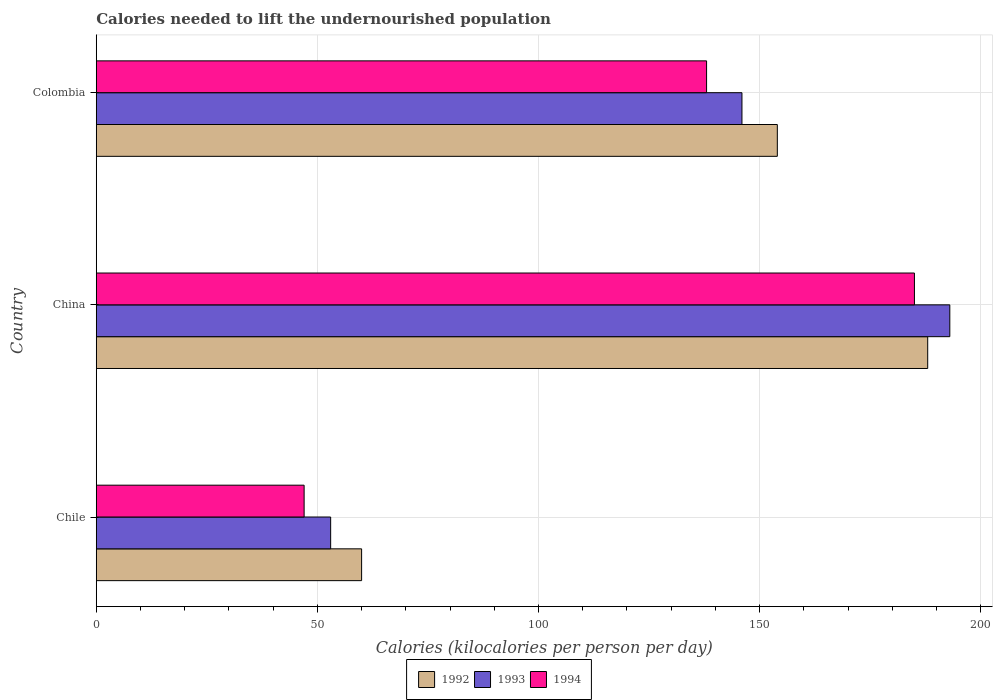How many different coloured bars are there?
Ensure brevity in your answer.  3. How many groups of bars are there?
Offer a very short reply. 3. Are the number of bars per tick equal to the number of legend labels?
Offer a terse response. Yes. Are the number of bars on each tick of the Y-axis equal?
Provide a succinct answer. Yes. How many bars are there on the 3rd tick from the top?
Ensure brevity in your answer.  3. What is the label of the 2nd group of bars from the top?
Make the answer very short. China. In how many cases, is the number of bars for a given country not equal to the number of legend labels?
Give a very brief answer. 0. Across all countries, what is the maximum total calories needed to lift the undernourished population in 1992?
Give a very brief answer. 188. In which country was the total calories needed to lift the undernourished population in 1992 minimum?
Keep it short and to the point. Chile. What is the total total calories needed to lift the undernourished population in 1994 in the graph?
Keep it short and to the point. 370. What is the difference between the total calories needed to lift the undernourished population in 1992 in Chile and that in China?
Your response must be concise. -128. What is the difference between the total calories needed to lift the undernourished population in 1992 in China and the total calories needed to lift the undernourished population in 1994 in Chile?
Your answer should be very brief. 141. What is the average total calories needed to lift the undernourished population in 1992 per country?
Ensure brevity in your answer.  134. What is the difference between the total calories needed to lift the undernourished population in 1994 and total calories needed to lift the undernourished population in 1992 in China?
Make the answer very short. -3. What is the ratio of the total calories needed to lift the undernourished population in 1992 in China to that in Colombia?
Keep it short and to the point. 1.22. Is the total calories needed to lift the undernourished population in 1994 in Chile less than that in China?
Ensure brevity in your answer.  Yes. What is the difference between the highest and the lowest total calories needed to lift the undernourished population in 1992?
Your answer should be very brief. 128. Is the sum of the total calories needed to lift the undernourished population in 1994 in Chile and Colombia greater than the maximum total calories needed to lift the undernourished population in 1992 across all countries?
Give a very brief answer. No. What does the 1st bar from the top in Chile represents?
Make the answer very short. 1994. What does the 3rd bar from the bottom in Chile represents?
Your response must be concise. 1994. Is it the case that in every country, the sum of the total calories needed to lift the undernourished population in 1992 and total calories needed to lift the undernourished population in 1993 is greater than the total calories needed to lift the undernourished population in 1994?
Make the answer very short. Yes. How many countries are there in the graph?
Provide a short and direct response. 3. What is the difference between two consecutive major ticks on the X-axis?
Keep it short and to the point. 50. Are the values on the major ticks of X-axis written in scientific E-notation?
Give a very brief answer. No. Where does the legend appear in the graph?
Your answer should be compact. Bottom center. What is the title of the graph?
Your answer should be very brief. Calories needed to lift the undernourished population. What is the label or title of the X-axis?
Your answer should be very brief. Calories (kilocalories per person per day). What is the label or title of the Y-axis?
Ensure brevity in your answer.  Country. What is the Calories (kilocalories per person per day) in 1993 in Chile?
Keep it short and to the point. 53. What is the Calories (kilocalories per person per day) in 1994 in Chile?
Your response must be concise. 47. What is the Calories (kilocalories per person per day) in 1992 in China?
Keep it short and to the point. 188. What is the Calories (kilocalories per person per day) in 1993 in China?
Provide a succinct answer. 193. What is the Calories (kilocalories per person per day) of 1994 in China?
Your answer should be compact. 185. What is the Calories (kilocalories per person per day) of 1992 in Colombia?
Make the answer very short. 154. What is the Calories (kilocalories per person per day) of 1993 in Colombia?
Your answer should be compact. 146. What is the Calories (kilocalories per person per day) in 1994 in Colombia?
Make the answer very short. 138. Across all countries, what is the maximum Calories (kilocalories per person per day) of 1992?
Keep it short and to the point. 188. Across all countries, what is the maximum Calories (kilocalories per person per day) in 1993?
Your answer should be very brief. 193. Across all countries, what is the maximum Calories (kilocalories per person per day) of 1994?
Provide a succinct answer. 185. Across all countries, what is the minimum Calories (kilocalories per person per day) of 1992?
Ensure brevity in your answer.  60. What is the total Calories (kilocalories per person per day) in 1992 in the graph?
Ensure brevity in your answer.  402. What is the total Calories (kilocalories per person per day) in 1993 in the graph?
Your answer should be very brief. 392. What is the total Calories (kilocalories per person per day) in 1994 in the graph?
Your response must be concise. 370. What is the difference between the Calories (kilocalories per person per day) in 1992 in Chile and that in China?
Provide a short and direct response. -128. What is the difference between the Calories (kilocalories per person per day) in 1993 in Chile and that in China?
Give a very brief answer. -140. What is the difference between the Calories (kilocalories per person per day) in 1994 in Chile and that in China?
Keep it short and to the point. -138. What is the difference between the Calories (kilocalories per person per day) in 1992 in Chile and that in Colombia?
Make the answer very short. -94. What is the difference between the Calories (kilocalories per person per day) of 1993 in Chile and that in Colombia?
Keep it short and to the point. -93. What is the difference between the Calories (kilocalories per person per day) in 1994 in Chile and that in Colombia?
Your answer should be very brief. -91. What is the difference between the Calories (kilocalories per person per day) of 1992 in China and that in Colombia?
Keep it short and to the point. 34. What is the difference between the Calories (kilocalories per person per day) in 1994 in China and that in Colombia?
Your response must be concise. 47. What is the difference between the Calories (kilocalories per person per day) of 1992 in Chile and the Calories (kilocalories per person per day) of 1993 in China?
Make the answer very short. -133. What is the difference between the Calories (kilocalories per person per day) in 1992 in Chile and the Calories (kilocalories per person per day) in 1994 in China?
Provide a short and direct response. -125. What is the difference between the Calories (kilocalories per person per day) of 1993 in Chile and the Calories (kilocalories per person per day) of 1994 in China?
Offer a terse response. -132. What is the difference between the Calories (kilocalories per person per day) in 1992 in Chile and the Calories (kilocalories per person per day) in 1993 in Colombia?
Provide a succinct answer. -86. What is the difference between the Calories (kilocalories per person per day) of 1992 in Chile and the Calories (kilocalories per person per day) of 1994 in Colombia?
Provide a succinct answer. -78. What is the difference between the Calories (kilocalories per person per day) in 1993 in Chile and the Calories (kilocalories per person per day) in 1994 in Colombia?
Provide a short and direct response. -85. What is the difference between the Calories (kilocalories per person per day) in 1993 in China and the Calories (kilocalories per person per day) in 1994 in Colombia?
Your response must be concise. 55. What is the average Calories (kilocalories per person per day) of 1992 per country?
Provide a succinct answer. 134. What is the average Calories (kilocalories per person per day) of 1993 per country?
Provide a short and direct response. 130.67. What is the average Calories (kilocalories per person per day) of 1994 per country?
Offer a terse response. 123.33. What is the difference between the Calories (kilocalories per person per day) of 1992 and Calories (kilocalories per person per day) of 1994 in Chile?
Offer a very short reply. 13. What is the difference between the Calories (kilocalories per person per day) in 1993 and Calories (kilocalories per person per day) in 1994 in Chile?
Offer a terse response. 6. What is the difference between the Calories (kilocalories per person per day) in 1992 and Calories (kilocalories per person per day) in 1994 in China?
Keep it short and to the point. 3. What is the difference between the Calories (kilocalories per person per day) in 1993 and Calories (kilocalories per person per day) in 1994 in China?
Your answer should be compact. 8. What is the difference between the Calories (kilocalories per person per day) in 1992 and Calories (kilocalories per person per day) in 1994 in Colombia?
Give a very brief answer. 16. What is the ratio of the Calories (kilocalories per person per day) of 1992 in Chile to that in China?
Provide a short and direct response. 0.32. What is the ratio of the Calories (kilocalories per person per day) of 1993 in Chile to that in China?
Your response must be concise. 0.27. What is the ratio of the Calories (kilocalories per person per day) in 1994 in Chile to that in China?
Keep it short and to the point. 0.25. What is the ratio of the Calories (kilocalories per person per day) in 1992 in Chile to that in Colombia?
Keep it short and to the point. 0.39. What is the ratio of the Calories (kilocalories per person per day) of 1993 in Chile to that in Colombia?
Keep it short and to the point. 0.36. What is the ratio of the Calories (kilocalories per person per day) of 1994 in Chile to that in Colombia?
Keep it short and to the point. 0.34. What is the ratio of the Calories (kilocalories per person per day) of 1992 in China to that in Colombia?
Give a very brief answer. 1.22. What is the ratio of the Calories (kilocalories per person per day) in 1993 in China to that in Colombia?
Offer a terse response. 1.32. What is the ratio of the Calories (kilocalories per person per day) of 1994 in China to that in Colombia?
Give a very brief answer. 1.34. What is the difference between the highest and the second highest Calories (kilocalories per person per day) in 1993?
Provide a short and direct response. 47. What is the difference between the highest and the lowest Calories (kilocalories per person per day) in 1992?
Your answer should be very brief. 128. What is the difference between the highest and the lowest Calories (kilocalories per person per day) in 1993?
Keep it short and to the point. 140. What is the difference between the highest and the lowest Calories (kilocalories per person per day) of 1994?
Ensure brevity in your answer.  138. 